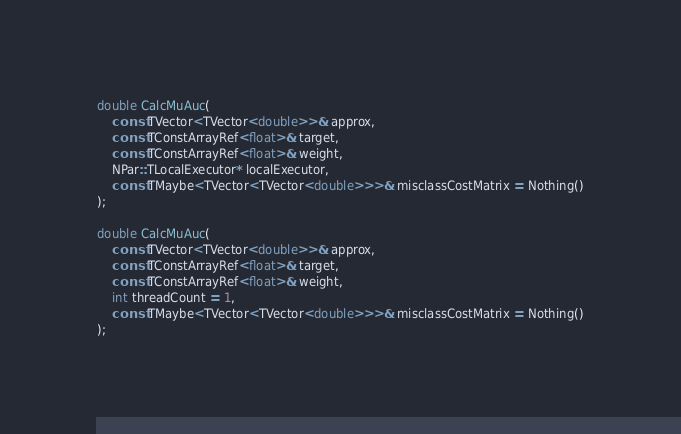<code> <loc_0><loc_0><loc_500><loc_500><_C_>
double CalcMuAuc(
    const TVector<TVector<double>>& approx,
    const TConstArrayRef<float>& target,
    const TConstArrayRef<float>& weight,
    NPar::TLocalExecutor* localExecutor,
    const TMaybe<TVector<TVector<double>>>& misclassCostMatrix = Nothing()
);

double CalcMuAuc(
    const TVector<TVector<double>>& approx,
    const TConstArrayRef<float>& target,
    const TConstArrayRef<float>& weight,
    int threadCount = 1,
    const TMaybe<TVector<TVector<double>>>& misclassCostMatrix = Nothing()
);
</code> 